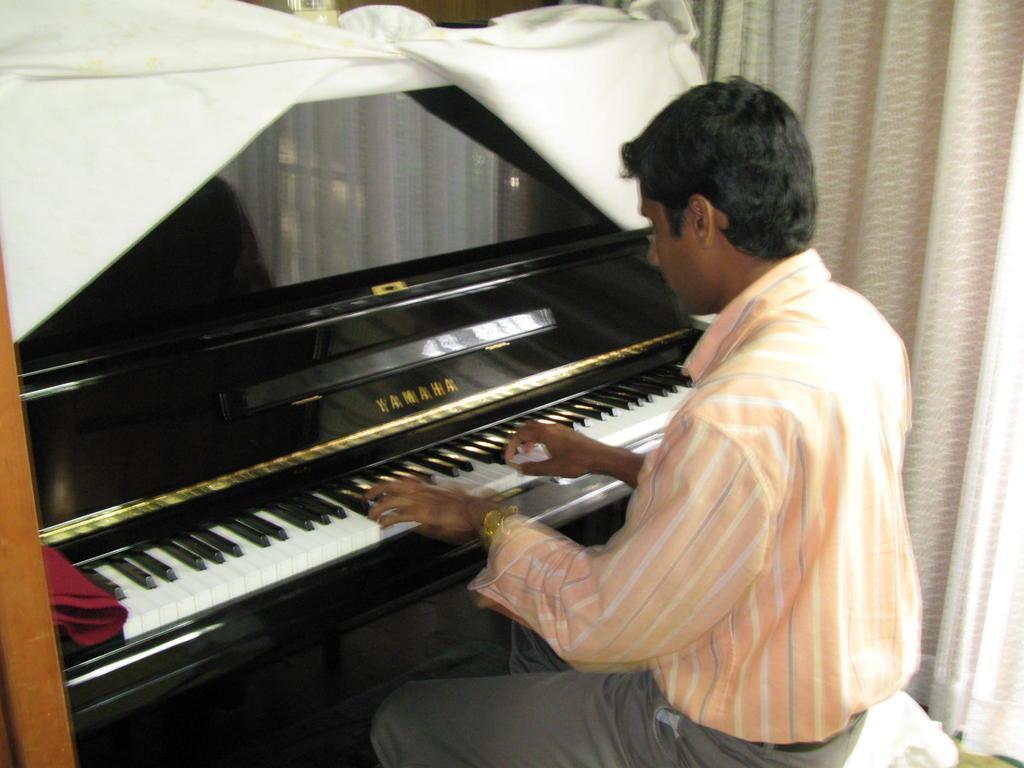In one or two sentences, can you explain what this image depicts? The person is sitting in a chair and playing piano which has Yamaha written on it. 